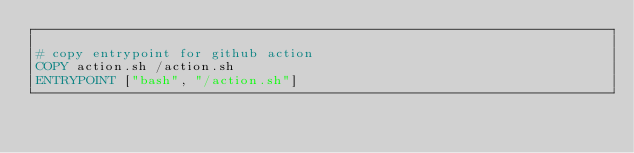Convert code to text. <code><loc_0><loc_0><loc_500><loc_500><_Dockerfile_>
# copy entrypoint for github action
COPY action.sh /action.sh
ENTRYPOINT ["bash", "/action.sh"]
</code> 